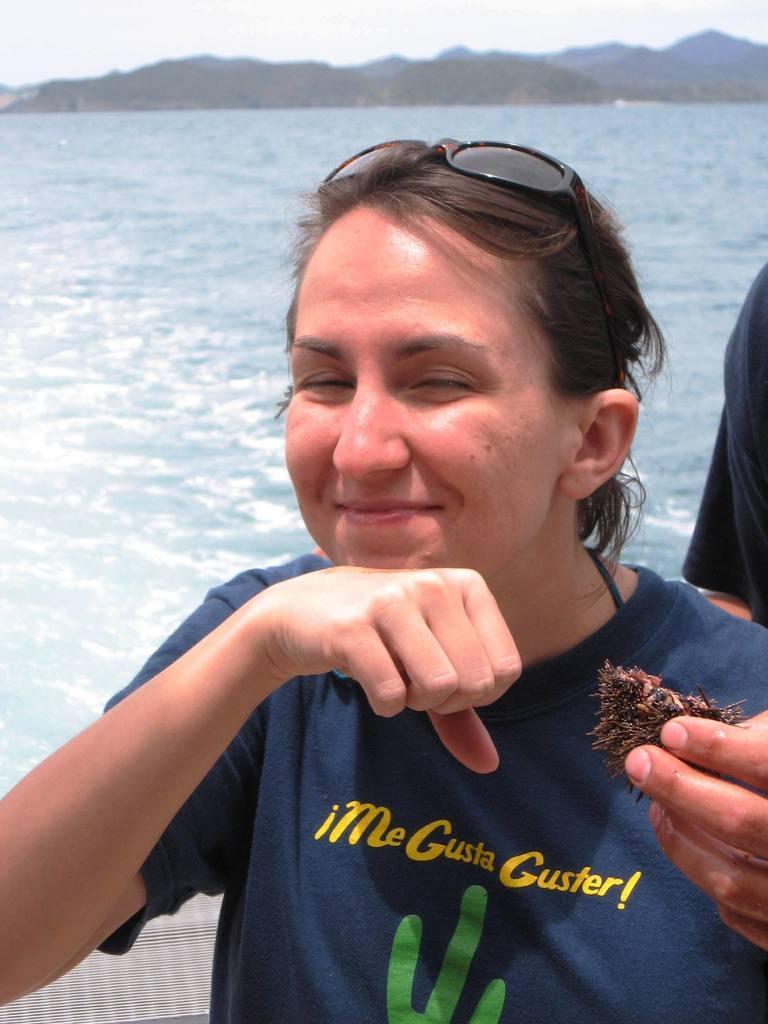Describe this image in one or two sentences. In this image in the front there is a woman smiling and holding an object in her hand and in the background there is an object which is black in colour and there is an ocean, there are mountains. 